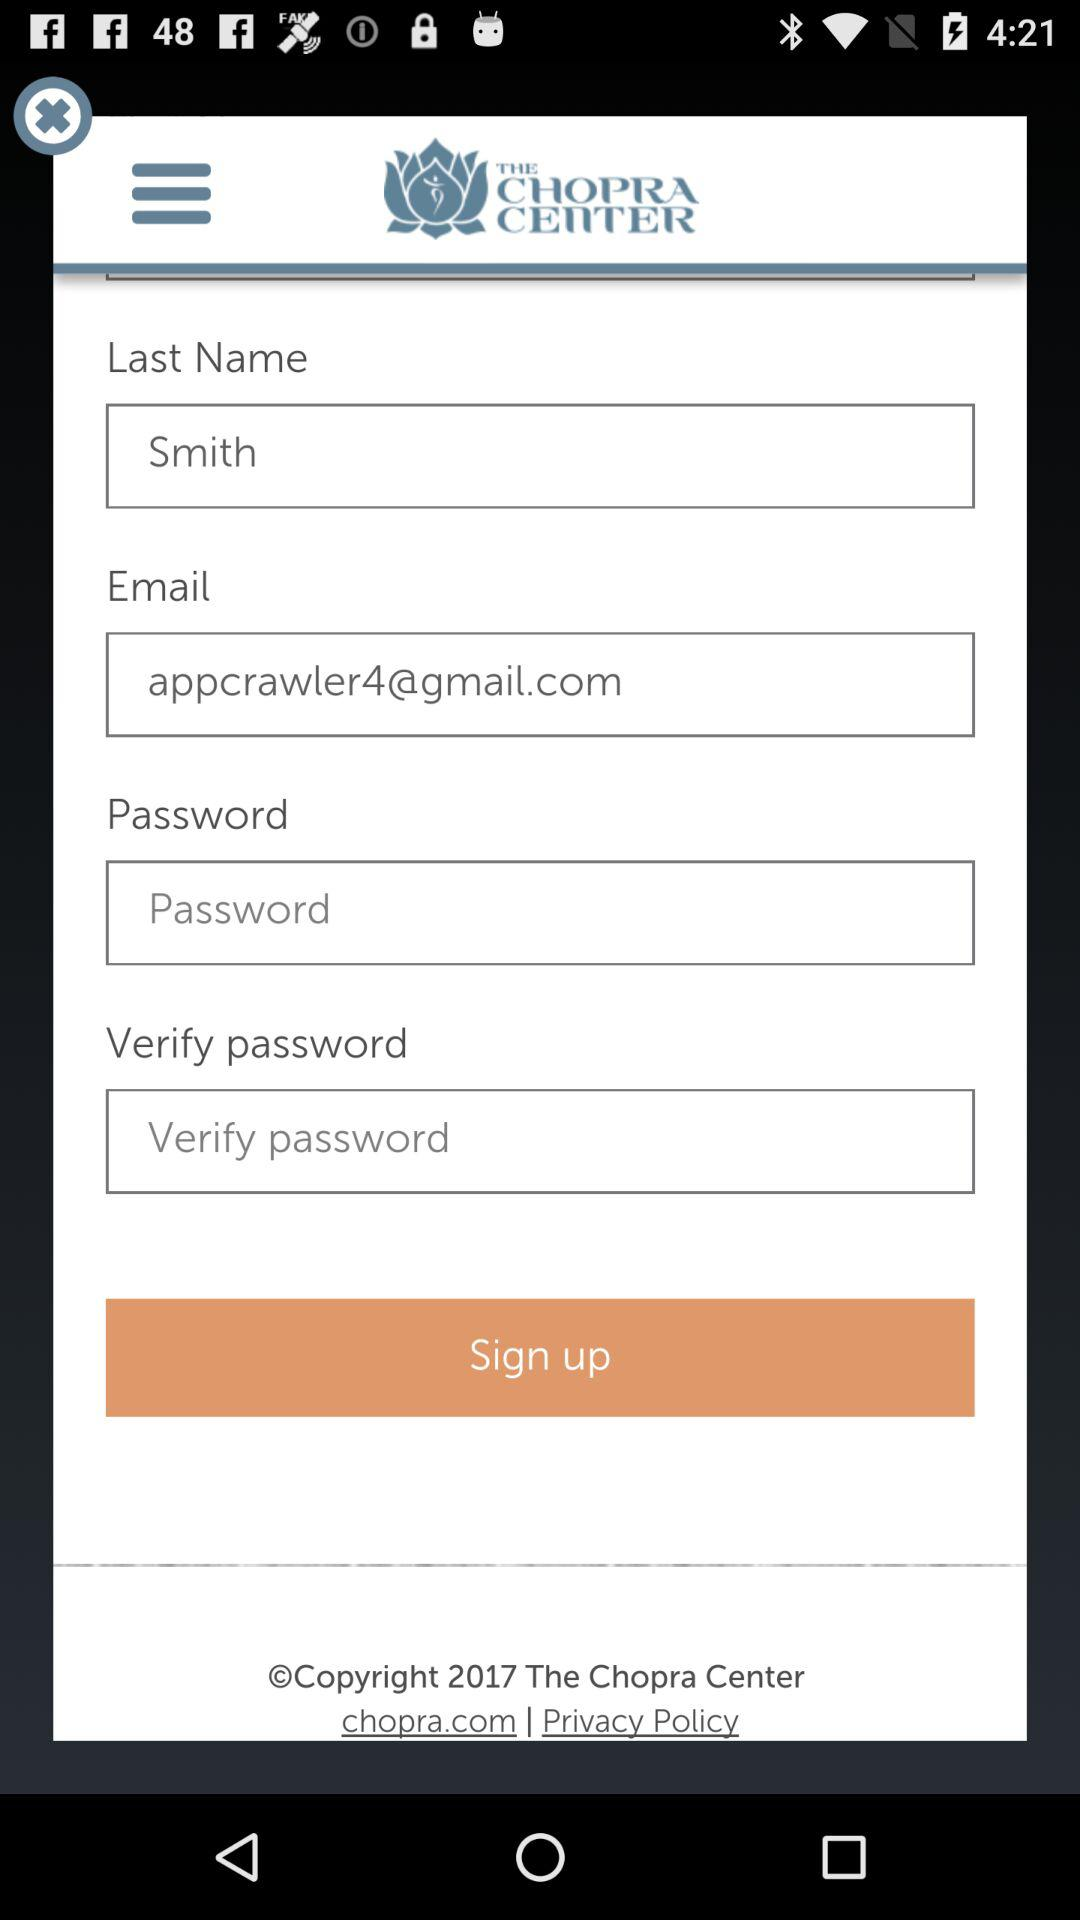What's the last name of the user? The last name of the user is Smith. 